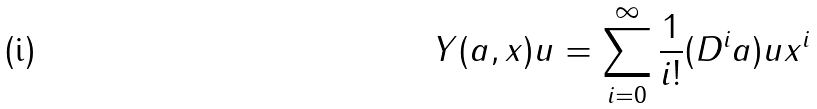<formula> <loc_0><loc_0><loc_500><loc_500>Y ( a , x ) u & = \sum _ { i = 0 } ^ { \infty } \frac { 1 } { i ! } ( D ^ { i } a ) u x ^ { i }</formula> 